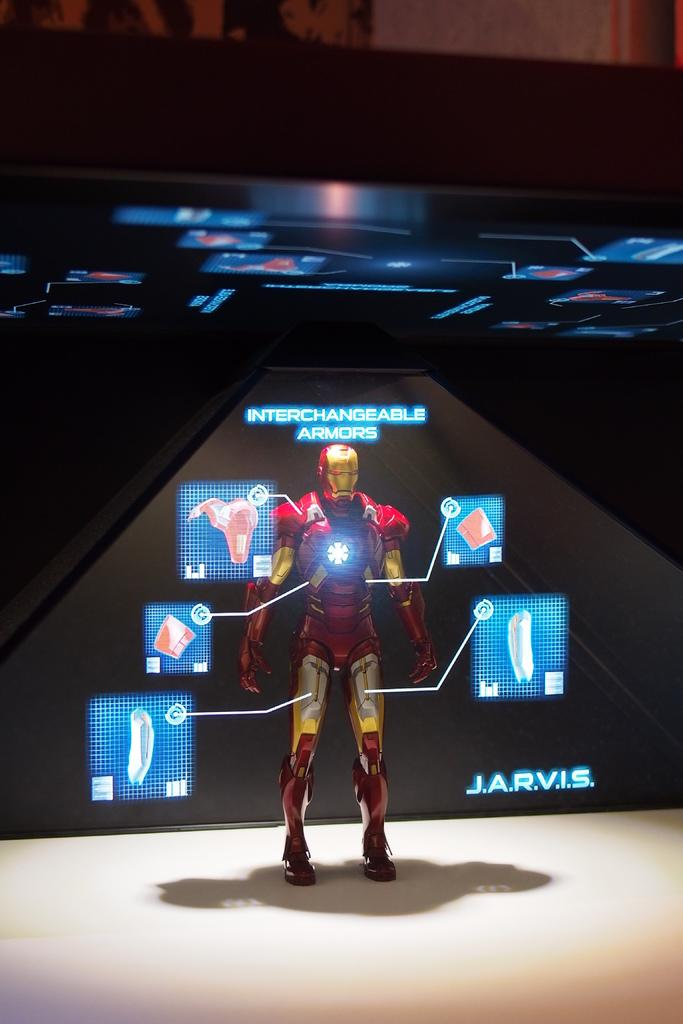Provide a one-sentence caption for the provided image. A display of a figure wearing red and gold interchangeable armor. 